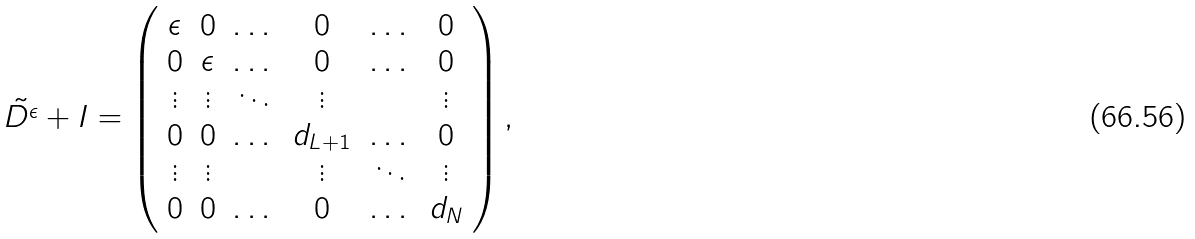<formula> <loc_0><loc_0><loc_500><loc_500>\tilde { D ^ { \epsilon } } + I = \left ( \begin{array} { c c c c c c } \epsilon & 0 & \dots & 0 & \dots & 0 \\ 0 & \epsilon & \dots & 0 & \dots & 0 \\ \vdots & \vdots & \ddots & \vdots & & \vdots \\ 0 & 0 & \dots & d _ { L + 1 } & \dots & 0 \\ \vdots & \vdots & & \vdots & \ddots & \vdots \\ 0 & 0 & \dots & 0 & \dots & d _ { N } \\ \end{array} \right ) ,</formula> 